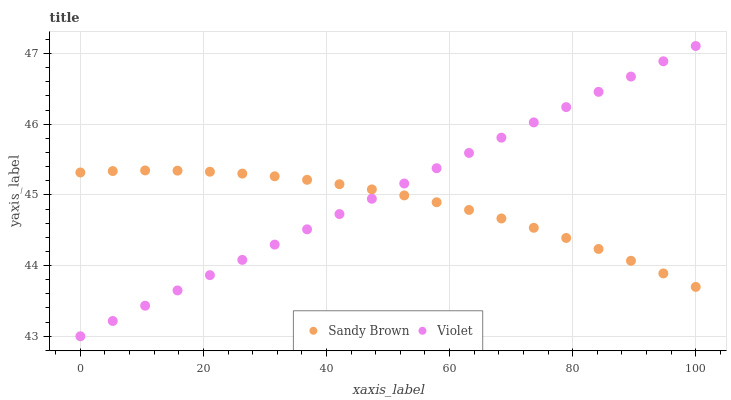Does Sandy Brown have the minimum area under the curve?
Answer yes or no. Yes. Does Violet have the maximum area under the curve?
Answer yes or no. Yes. Does Violet have the minimum area under the curve?
Answer yes or no. No. Is Violet the smoothest?
Answer yes or no. Yes. Is Sandy Brown the roughest?
Answer yes or no. Yes. Is Violet the roughest?
Answer yes or no. No. Does Violet have the lowest value?
Answer yes or no. Yes. Does Violet have the highest value?
Answer yes or no. Yes. Does Sandy Brown intersect Violet?
Answer yes or no. Yes. Is Sandy Brown less than Violet?
Answer yes or no. No. Is Sandy Brown greater than Violet?
Answer yes or no. No. 